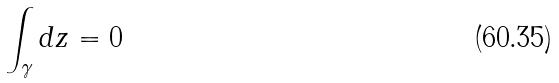Convert formula to latex. <formula><loc_0><loc_0><loc_500><loc_500>\int _ { \gamma } d z = 0</formula> 